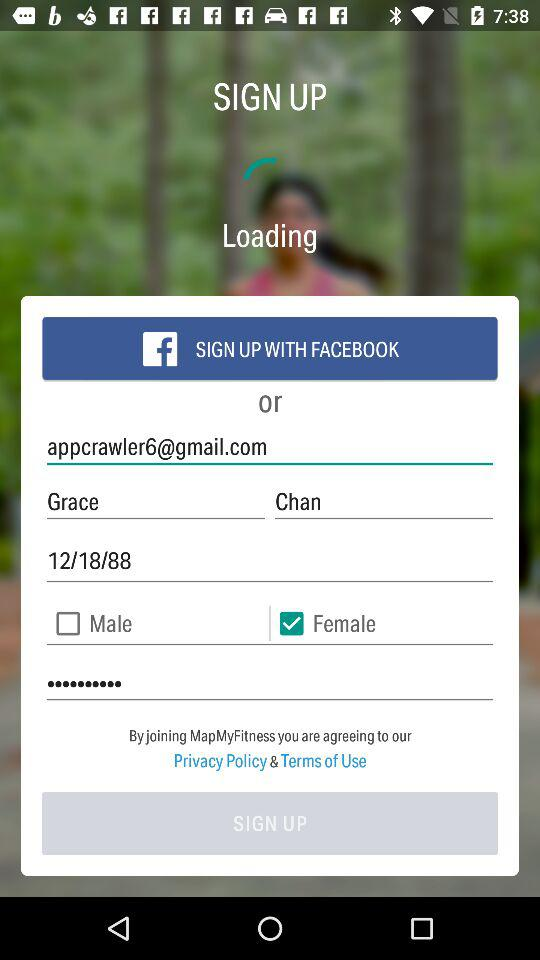What is the selected gender? The selected gender is female. 